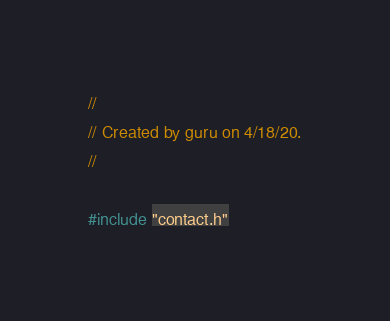Convert code to text. <code><loc_0><loc_0><loc_500><loc_500><_C++_>//
// Created by guru on 4/18/20.
//

#include "contact.h"
</code> 